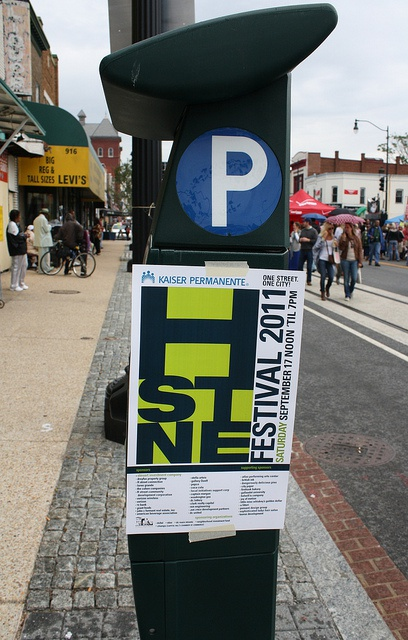Describe the objects in this image and their specific colors. I can see parking meter in black, blue, darkblue, and navy tones, people in black, darkgray, and gray tones, people in black, gray, darkgray, and maroon tones, people in black, maroon, gray, and darkblue tones, and people in black, darkgray, and gray tones in this image. 